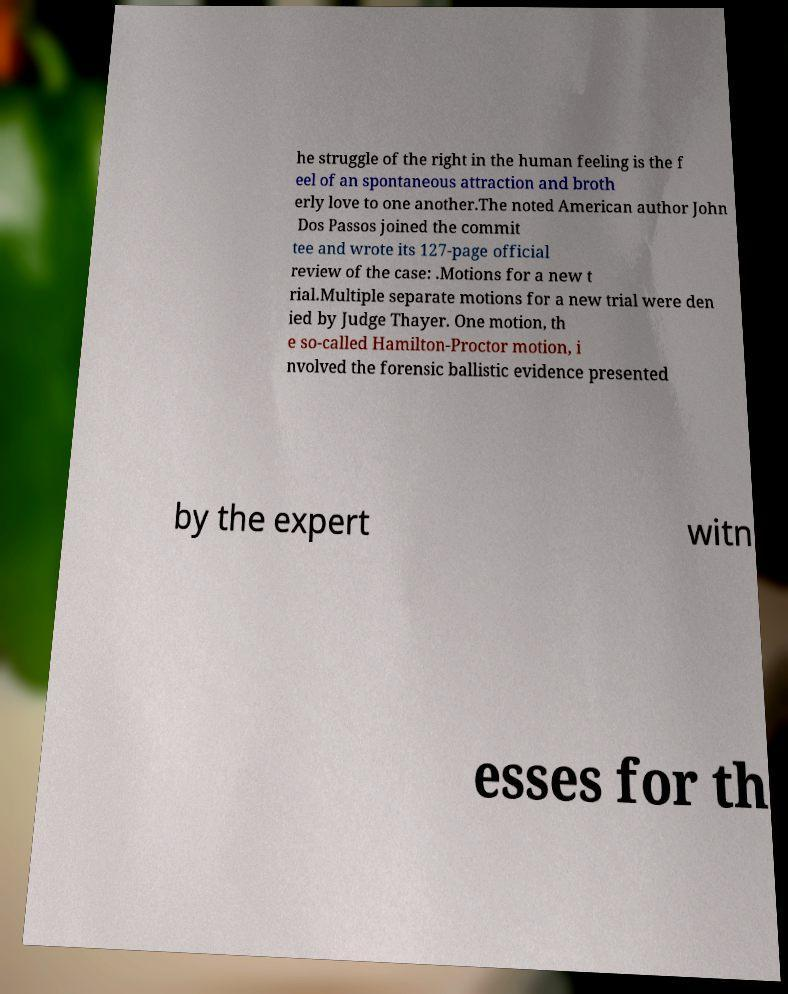Please read and relay the text visible in this image. What does it say? he struggle of the right in the human feeling is the f eel of an spontaneous attraction and broth erly love to one another.The noted American author John Dos Passos joined the commit tee and wrote its 127-page official review of the case: .Motions for a new t rial.Multiple separate motions for a new trial were den ied by Judge Thayer. One motion, th e so-called Hamilton-Proctor motion, i nvolved the forensic ballistic evidence presented by the expert witn esses for th 